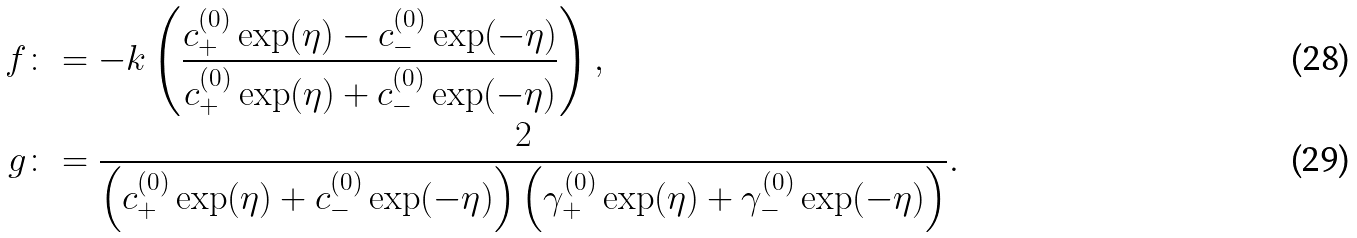Convert formula to latex. <formula><loc_0><loc_0><loc_500><loc_500>f & \colon = - k \left ( \frac { c _ { + } ^ { ( 0 ) } \exp ( \eta ) - c _ { - } ^ { ( 0 ) } \exp ( - \eta ) } { c _ { + } ^ { ( 0 ) } \exp ( \eta ) + c _ { - } ^ { ( 0 ) } \exp ( - \eta ) } \right ) , \\ g & \colon = \frac { 2 } { \left ( c _ { + } ^ { ( 0 ) } \exp ( \eta ) + c _ { - } ^ { ( 0 ) } \exp ( - \eta ) \right ) \left ( \gamma _ { + } ^ { ( 0 ) } \exp ( \eta ) + \gamma _ { - } ^ { ( 0 ) } \exp ( - \eta ) \right ) } .</formula> 